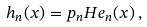Convert formula to latex. <formula><loc_0><loc_0><loc_500><loc_500>h _ { n } ( x ) = p _ { n } H e _ { n } ( x ) \, ,</formula> 